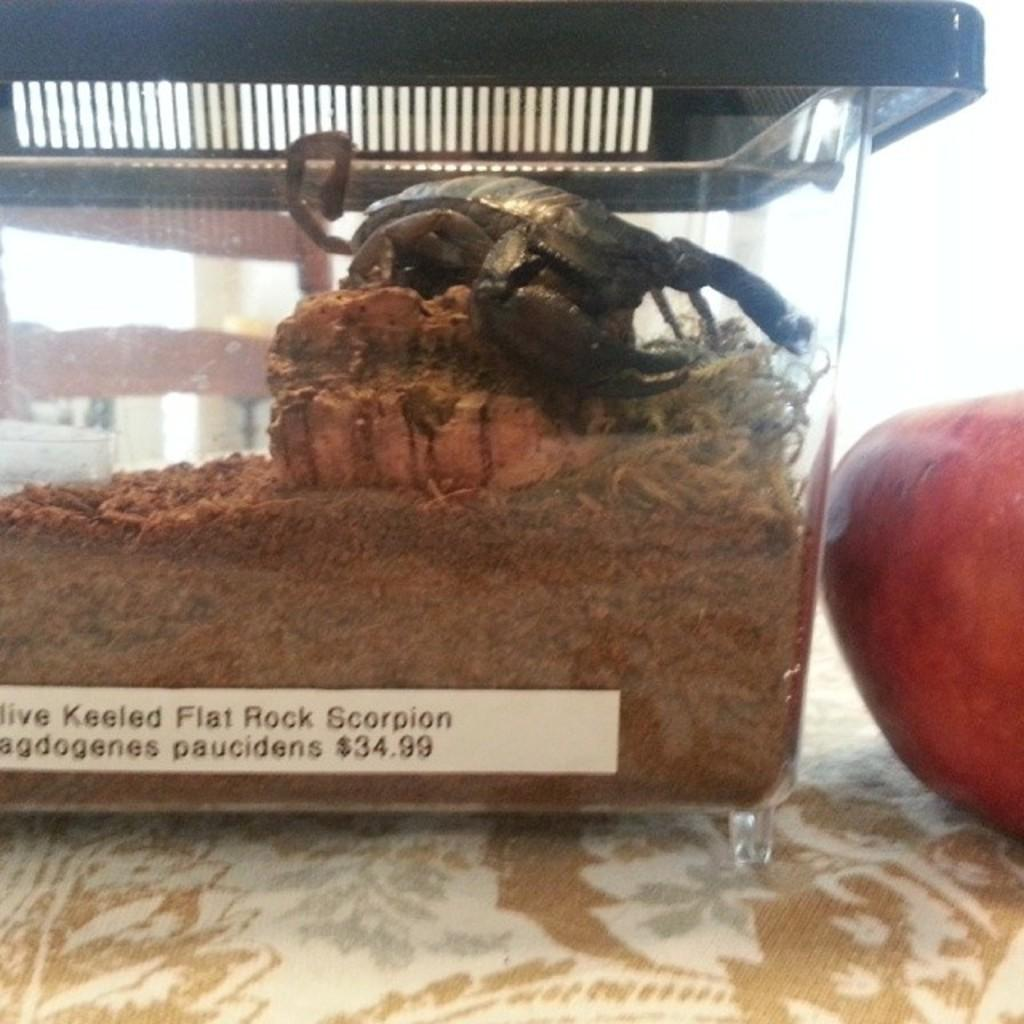What type of animal is in the image? There is a black crab in the image. How is the crab contained in the image? The crab is inside a glass box. What is present at the bottom of the glass box? There is sand in the glass box. What is the crab positioned on in the glass box? The crab is on a stone in the glass box. What is located on the right side of the image? There is an apple on the right side of the image. What health benefits does the apple provide in the image? The image does not provide information about the health benefits of the apple. How does the presence of the crab in the glass box make you feel? The image does not elicit any specific emotions or feelings. 